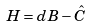Convert formula to latex. <formula><loc_0><loc_0><loc_500><loc_500>H = d B - \hat { C }</formula> 